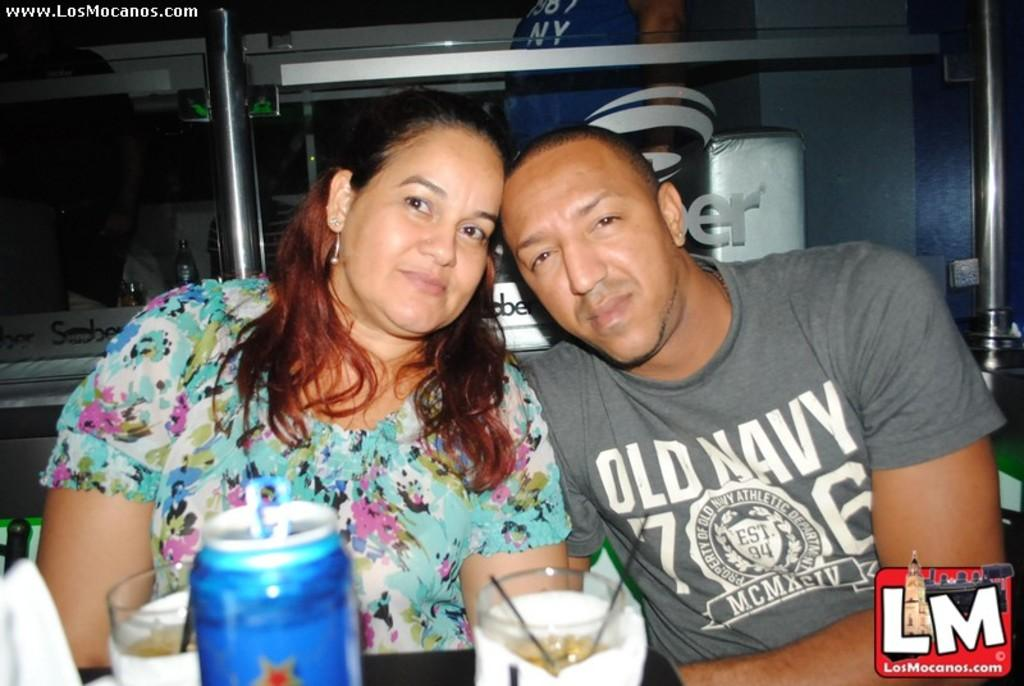How many people are sitting in the image? There are two people sitting in the image. What are the people wearing? The people are wearing different color dresses. What objects can be seen on the table? There are glasses and thin objects on the table. What can be seen in the background of the image? There are a few objects visible in the background. Can you tell me the direction the snake is moving in the image? There is no snake present in the image, so it is not possible to determine the direction it might be moving. 